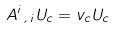<formula> <loc_0><loc_0><loc_500><loc_500>A ^ { i } \xi _ { i } U _ { c } = v _ { c } U _ { c }</formula> 